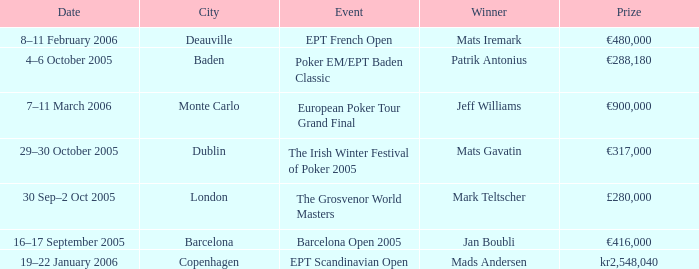What city did an event have a prize of €288,180? Baden. 